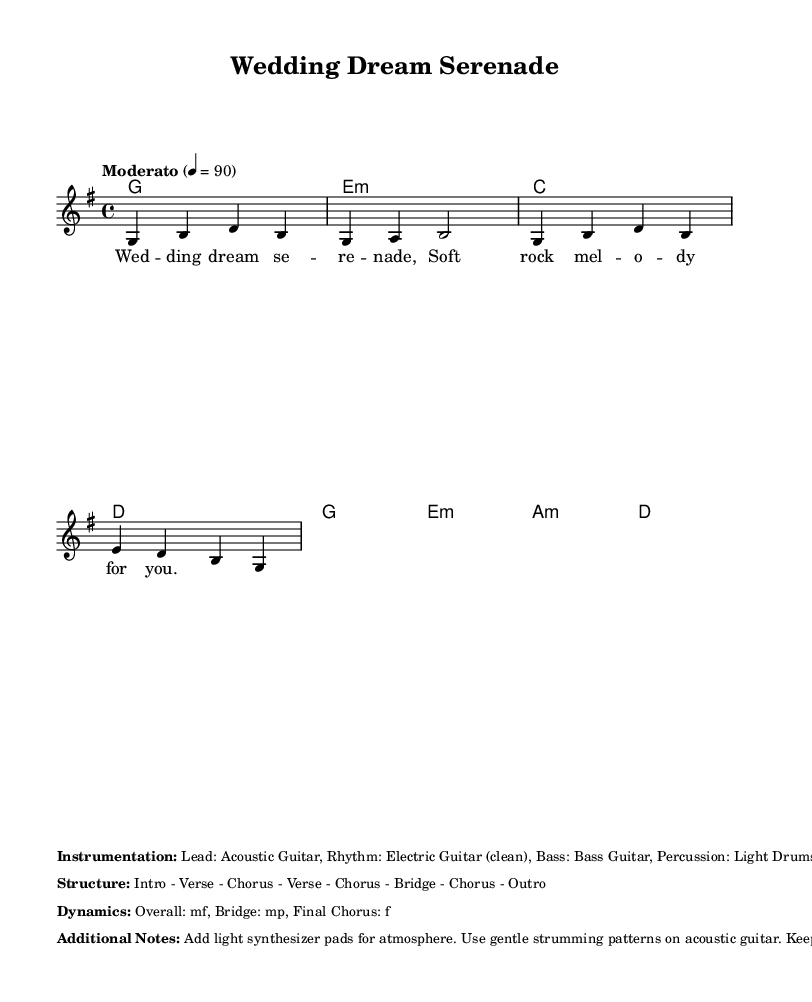What is the key signature of this music? The key signature is G major, which has one sharp (F#). This can be determined by looking at the key signature indicated at the beginning of the score.
Answer: G major What is the time signature of this piece? The time signature is 4/4, which is indicated at the beginning of the sheet music. This means there are four beats in each measure.
Answer: 4/4 What is the tempo marking for this piece? The tempo marking is "Moderato," which suggests a moderate speed. This is indicated near the beginning of the score where tempo is specified.
Answer: Moderato How many measures are there in the melody? There are eight measures in the melody. By counting the groups of notes and their corresponding bar lines in the melody section, you can determine the number of measures.
Answer: 8 What instrument plays the lead? The lead instrument is the Acoustic Guitar, which is specified in the instrumentation section below the score.
Answer: Acoustic Guitar What is the overall dynamic marking for the piece? The overall dynamic marking is mf, which stands for mezzo-forte, indicating a moderate volume. This can be found in the dynamics section of the sheet music.
Answer: mf What is the primary structure of the song? The primary structure of the song is Intro - Verse - Chorus - Verse - Chorus - Bridge - Chorus - Outro. This structure is listed in the notes following the music.
Answer: Intro - Verse - Chorus - Verse - Chorus - Bridge - Chorus - Outro 